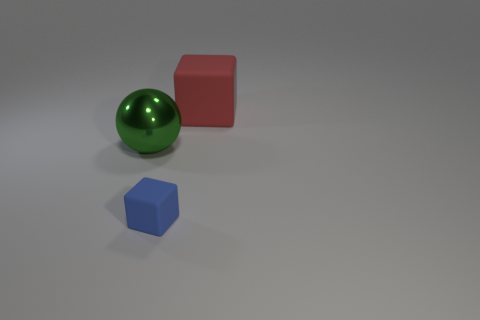Is there any other thing that has the same material as the large green ball?
Your answer should be very brief. No. There is a tiny object that is made of the same material as the big block; what shape is it?
Your answer should be very brief. Cube. How many things are metal spheres or small blue matte things?
Your answer should be very brief. 2. The cube that is in front of the rubber block behind the green thing is made of what material?
Ensure brevity in your answer.  Rubber. Is there a big yellow block that has the same material as the small cube?
Provide a short and direct response. No. The large object that is left of the matte object that is to the right of the rubber thing in front of the large matte thing is what shape?
Keep it short and to the point. Sphere. What is the material of the red cube?
Offer a very short reply. Rubber. There is a block that is made of the same material as the blue object; what is its color?
Your answer should be very brief. Red. Are there any blue rubber things to the left of the matte block behind the big green shiny ball?
Offer a very short reply. Yes. How many other objects are the same shape as the blue matte thing?
Offer a terse response. 1. 